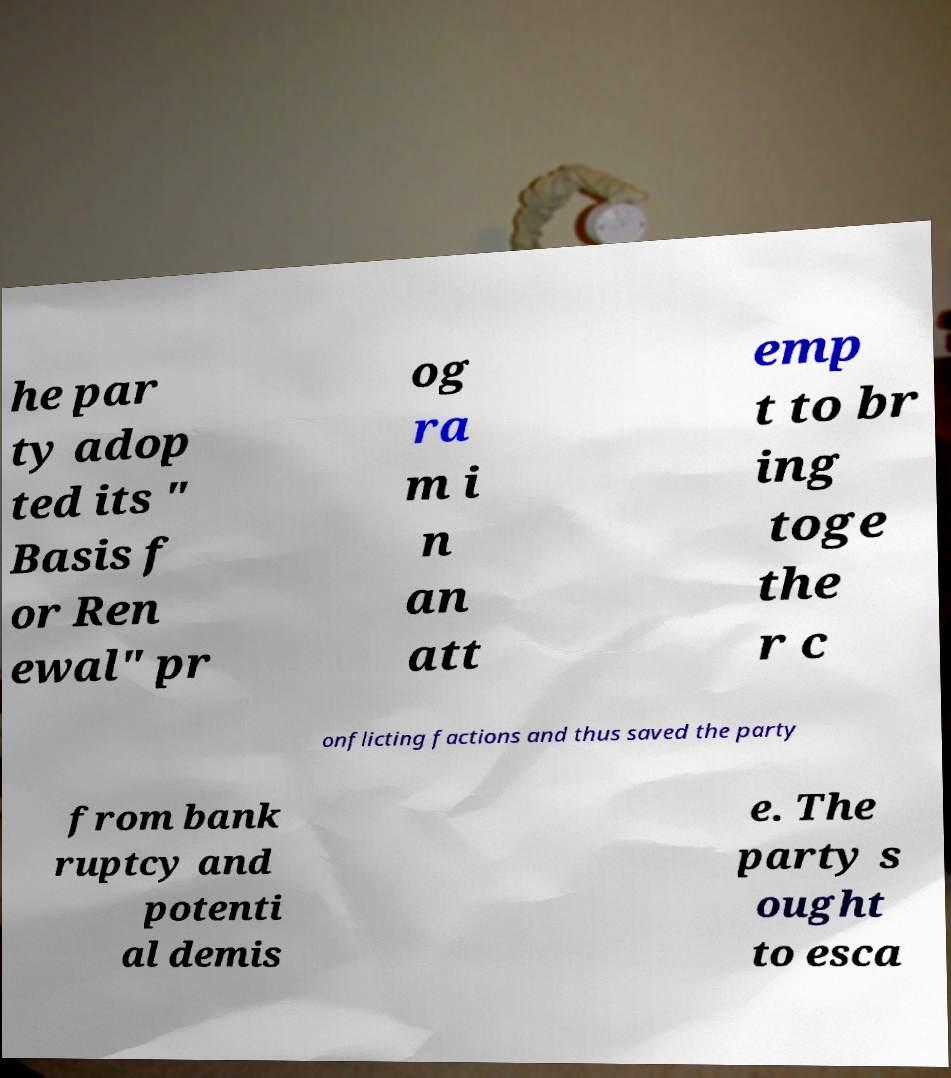What messages or text are displayed in this image? I need them in a readable, typed format. he par ty adop ted its " Basis f or Ren ewal" pr og ra m i n an att emp t to br ing toge the r c onflicting factions and thus saved the party from bank ruptcy and potenti al demis e. The party s ought to esca 